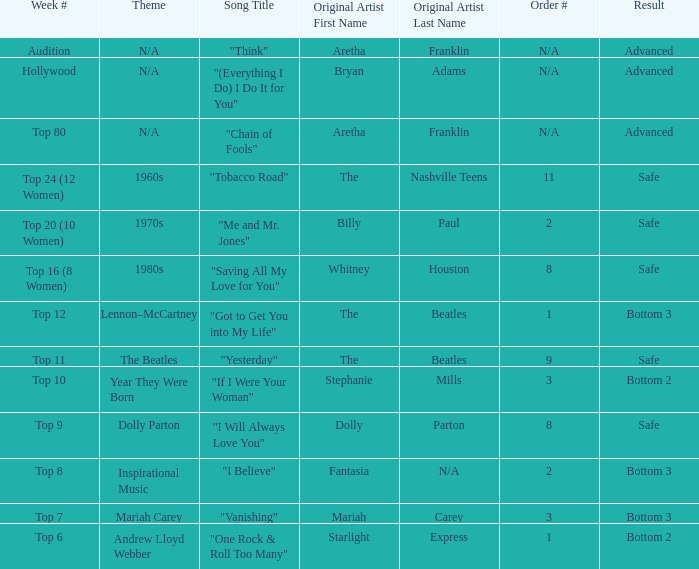Name the song choice when week number is hollywood " (Everything I Do) I Do It for You ". 